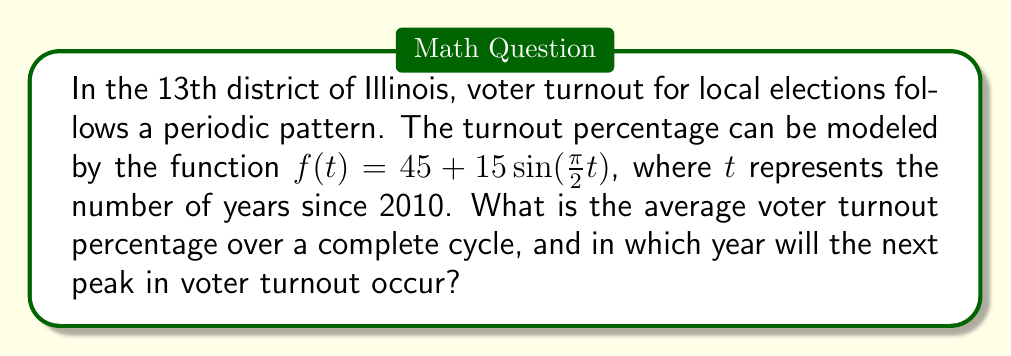Help me with this question. To solve this problem, let's break it down into steps:

1. Average voter turnout:
   The function $f(t) = 45 + 15\sin(\frac{\pi}{2}t)$ is a sinusoidal function.
   The average value of a sinusoidal function over a complete cycle is equal to its vertical shift.
   In this case, the vertical shift is 45%.

2. Period of the function:
   The period of $\sin(at)$ is $\frac{2\pi}{|a|}$.
   Here, $a = \frac{\pi}{2}$, so the period is $\frac{2\pi}{|\frac{\pi}{2}|} = 4$ years.

3. Next peak in voter turnout:
   Peaks occur when $\sin(\frac{\pi}{2}t) = 1$, which happens when $\frac{\pi}{2}t = \frac{\pi}{2} + 2\pi n$, where $n$ is an integer.
   Solving for $t$: $t = 1 + 4n$

   The first peak after 2010 occurred in 2011 (when $t = 1$).
   Subsequent peaks occur every 4 years: 2015, 2019, 2023, ...

   The next peak after the current year (2023) will be in 2027.
Answer: 45%; 2027 